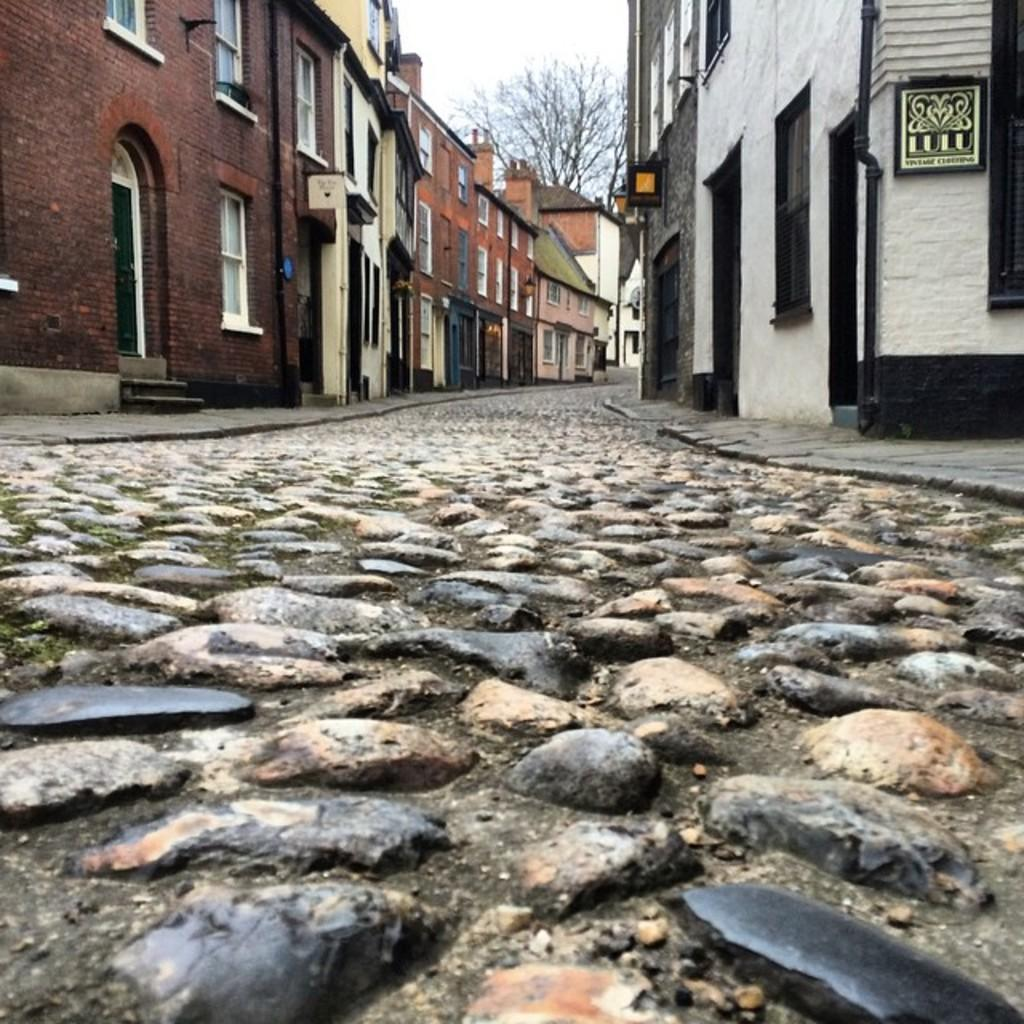What is the main feature of the image? There is a road in the image. How is the road positioned in relation to other structures? The road is situated between buildings. What type of natural element can be seen in the image? There is a tree at the top of the image. What type of chain is being used to cook food in the image? There is no chain or oven present in the image, so it is not possible to determine what type of chain might be used for cooking. 